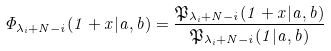Convert formula to latex. <formula><loc_0><loc_0><loc_500><loc_500>\Phi _ { \lambda _ { i } + N - i } ( 1 + x | a , b ) = \frac { \mathfrak { P } _ { \lambda _ { i } + N - i } ( 1 + x | a , b ) } { \mathfrak { P } _ { \lambda _ { i } + N - i } ( 1 | a , b ) }</formula> 